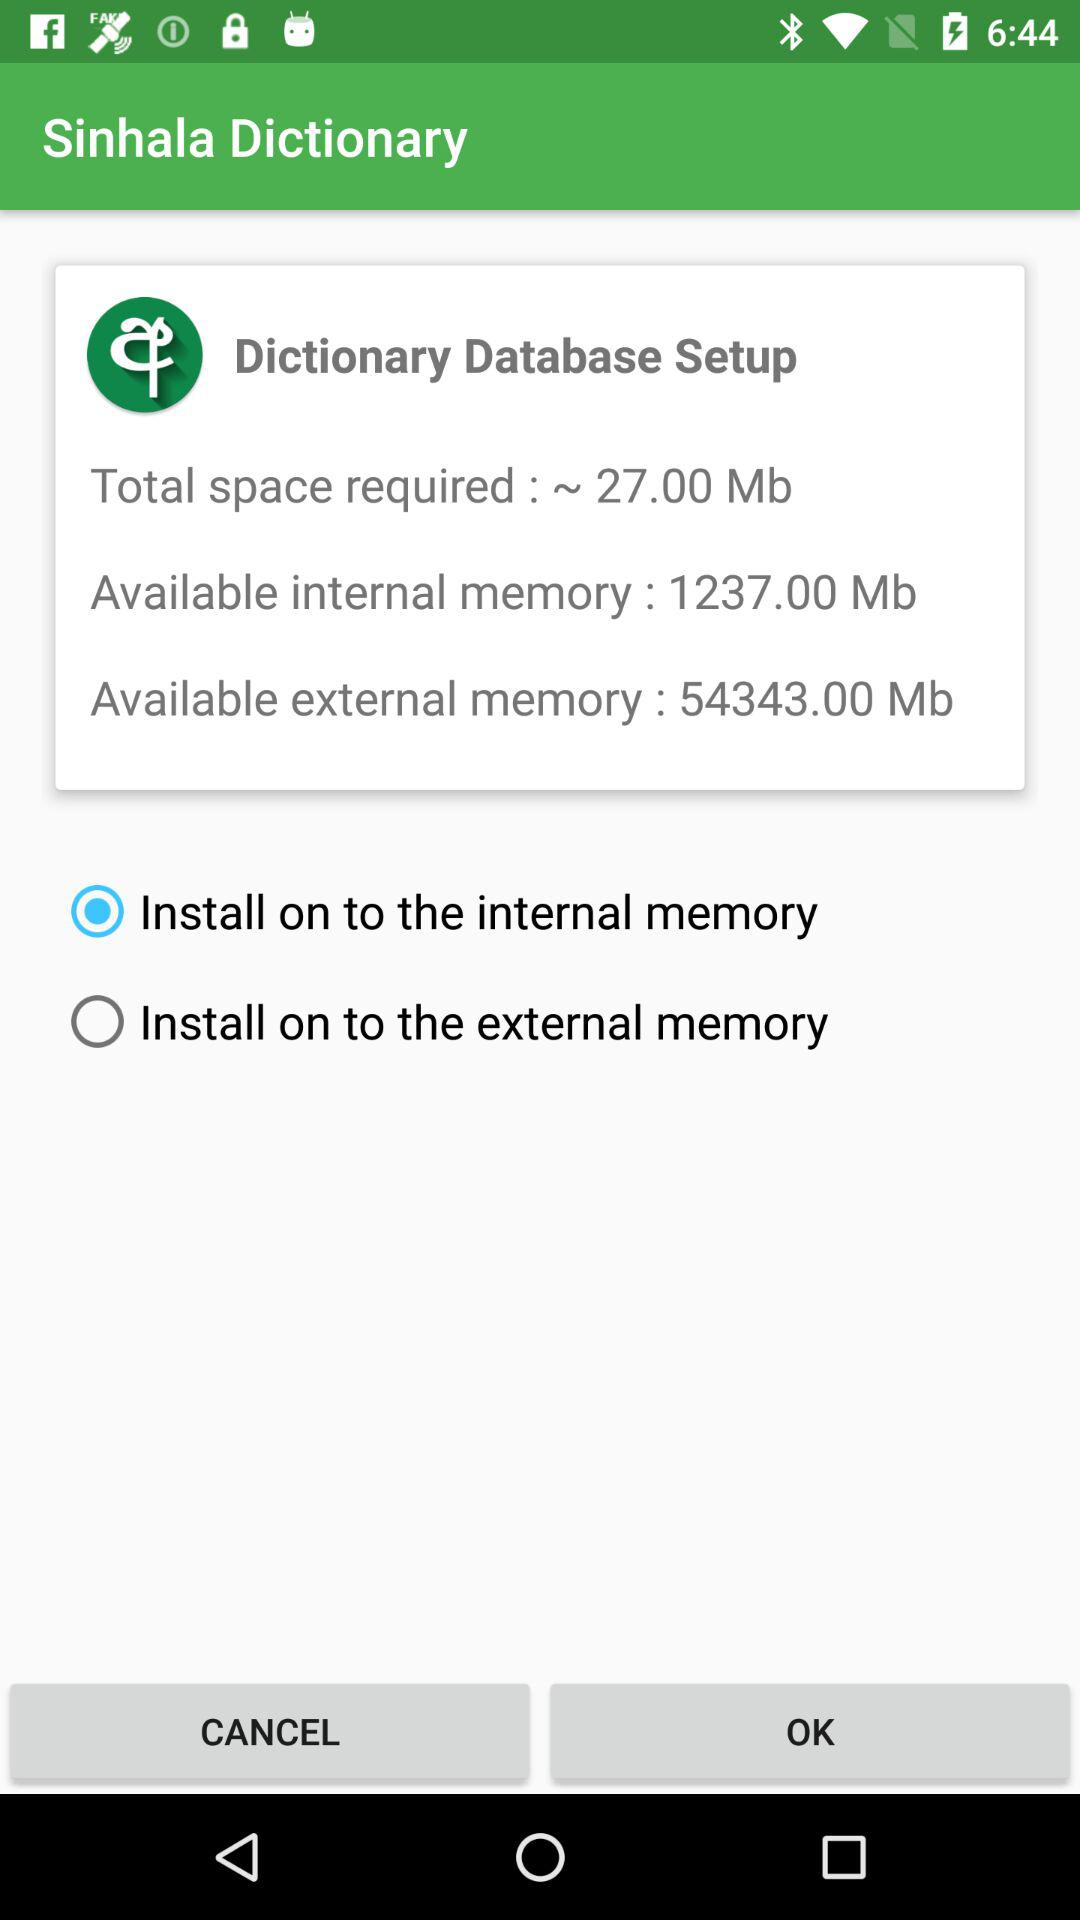How much total space is required for a dictionary database setup? The total required space is ~27.00 Mb. 